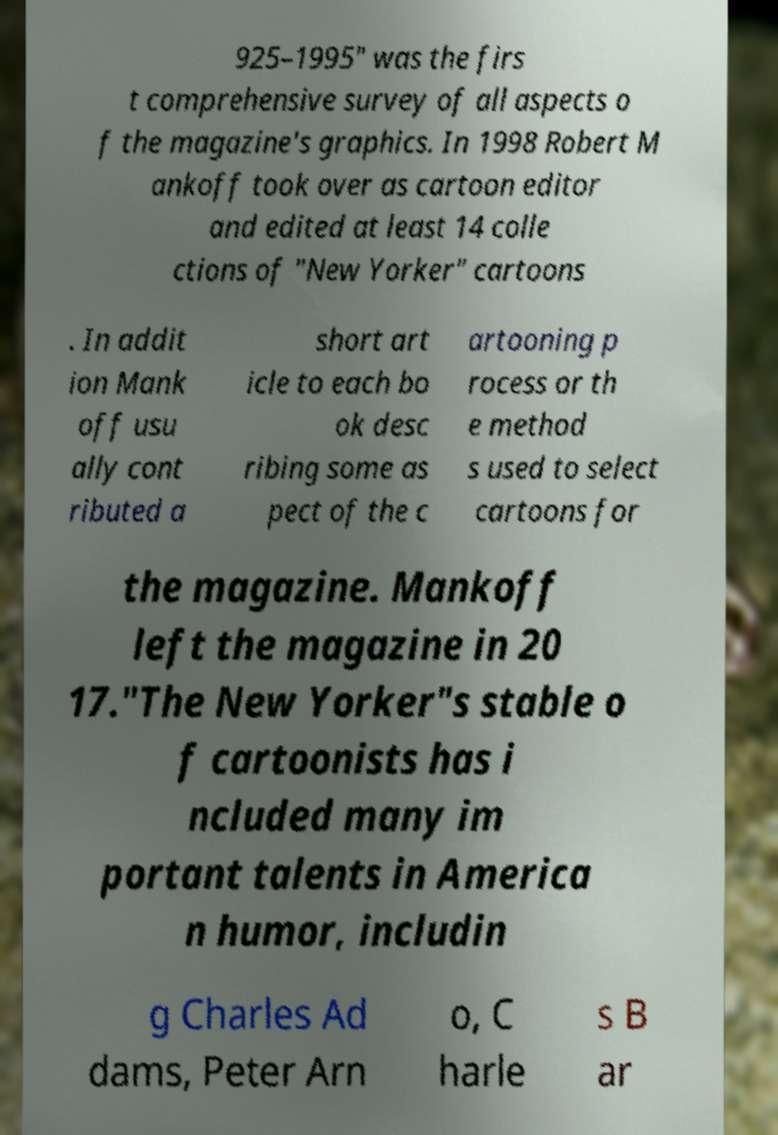Can you accurately transcribe the text from the provided image for me? 925–1995" was the firs t comprehensive survey of all aspects o f the magazine's graphics. In 1998 Robert M ankoff took over as cartoon editor and edited at least 14 colle ctions of "New Yorker" cartoons . In addit ion Mank off usu ally cont ributed a short art icle to each bo ok desc ribing some as pect of the c artooning p rocess or th e method s used to select cartoons for the magazine. Mankoff left the magazine in 20 17."The New Yorker"s stable o f cartoonists has i ncluded many im portant talents in America n humor, includin g Charles Ad dams, Peter Arn o, C harle s B ar 